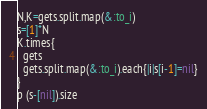Convert code to text. <code><loc_0><loc_0><loc_500><loc_500><_Ruby_>N,K=gets.split.map(&:to_i)
s=[1]*N
K.times{
  gets
  gets.split.map(&:to_i).each{|i|s[i-1]=nil}
}
p (s-[nil]).size</code> 